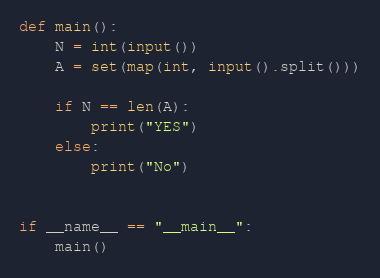<code> <loc_0><loc_0><loc_500><loc_500><_Python_>def main():
    N = int(input())
    A = set(map(int, input().split()))

    if N == len(A):
        print("YES")
    else:
        print("No")


if __name__ == "__main__":
    main()
</code> 